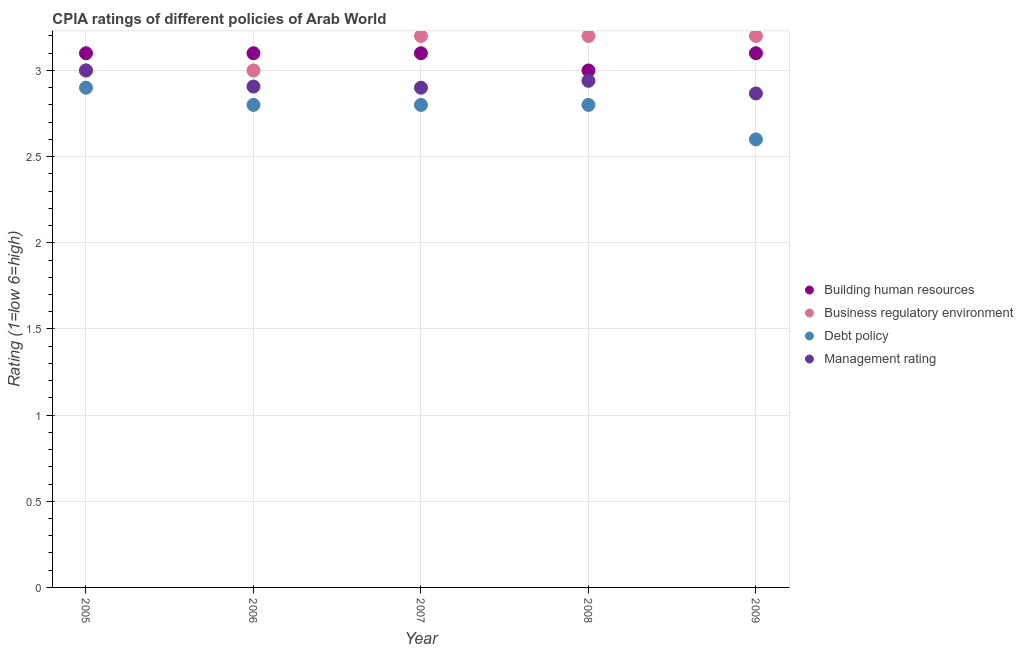What is the cpia rating of business regulatory environment in 2005?
Give a very brief answer. 3. Across all years, what is the minimum cpia rating of business regulatory environment?
Give a very brief answer. 3. In which year was the cpia rating of debt policy minimum?
Ensure brevity in your answer.  2009. What is the total cpia rating of building human resources in the graph?
Ensure brevity in your answer.  15.4. What is the difference between the cpia rating of building human resources in 2005 and that in 2008?
Ensure brevity in your answer.  0.1. What is the difference between the cpia rating of building human resources in 2006 and the cpia rating of management in 2005?
Give a very brief answer. 0.1. What is the average cpia rating of business regulatory environment per year?
Make the answer very short. 3.12. In the year 2009, what is the difference between the cpia rating of management and cpia rating of building human resources?
Offer a terse response. -0.23. In how many years, is the cpia rating of building human resources greater than 2.5?
Make the answer very short. 5. What is the ratio of the cpia rating of management in 2006 to that in 2007?
Ensure brevity in your answer.  1. Is the cpia rating of management in 2007 less than that in 2008?
Make the answer very short. Yes. What is the difference between the highest and the second highest cpia rating of building human resources?
Keep it short and to the point. 0. What is the difference between the highest and the lowest cpia rating of building human resources?
Provide a succinct answer. 0.1. In how many years, is the cpia rating of business regulatory environment greater than the average cpia rating of business regulatory environment taken over all years?
Offer a very short reply. 3. Is the sum of the cpia rating of management in 2008 and 2009 greater than the maximum cpia rating of business regulatory environment across all years?
Make the answer very short. Yes. Is it the case that in every year, the sum of the cpia rating of building human resources and cpia rating of business regulatory environment is greater than the cpia rating of debt policy?
Your response must be concise. Yes. Is the cpia rating of management strictly greater than the cpia rating of building human resources over the years?
Your answer should be compact. No. How many dotlines are there?
Keep it short and to the point. 4. Are the values on the major ticks of Y-axis written in scientific E-notation?
Offer a very short reply. No. Does the graph contain any zero values?
Your answer should be very brief. No. Does the graph contain grids?
Offer a very short reply. Yes. Where does the legend appear in the graph?
Make the answer very short. Center right. How many legend labels are there?
Offer a very short reply. 4. How are the legend labels stacked?
Provide a short and direct response. Vertical. What is the title of the graph?
Keep it short and to the point. CPIA ratings of different policies of Arab World. Does "SF6 gas" appear as one of the legend labels in the graph?
Your response must be concise. No. What is the label or title of the X-axis?
Keep it short and to the point. Year. What is the label or title of the Y-axis?
Provide a short and direct response. Rating (1=low 6=high). What is the Rating (1=low 6=high) in Debt policy in 2005?
Offer a very short reply. 2.9. What is the Rating (1=low 6=high) in Management rating in 2005?
Your response must be concise. 3. What is the Rating (1=low 6=high) of Business regulatory environment in 2006?
Your answer should be very brief. 3. What is the Rating (1=low 6=high) in Management rating in 2006?
Offer a very short reply. 2.91. What is the Rating (1=low 6=high) of Business regulatory environment in 2007?
Your answer should be compact. 3.2. What is the Rating (1=low 6=high) of Debt policy in 2007?
Provide a short and direct response. 2.8. What is the Rating (1=low 6=high) in Management rating in 2007?
Provide a short and direct response. 2.9. What is the Rating (1=low 6=high) of Building human resources in 2008?
Ensure brevity in your answer.  3. What is the Rating (1=low 6=high) in Business regulatory environment in 2008?
Offer a very short reply. 3.2. What is the Rating (1=low 6=high) of Debt policy in 2008?
Provide a succinct answer. 2.8. What is the Rating (1=low 6=high) in Management rating in 2008?
Keep it short and to the point. 2.94. What is the Rating (1=low 6=high) of Building human resources in 2009?
Offer a terse response. 3.1. What is the Rating (1=low 6=high) in Debt policy in 2009?
Provide a succinct answer. 2.6. What is the Rating (1=low 6=high) of Management rating in 2009?
Give a very brief answer. 2.87. Across all years, what is the maximum Rating (1=low 6=high) of Debt policy?
Your answer should be compact. 2.9. Across all years, what is the maximum Rating (1=low 6=high) in Management rating?
Your answer should be very brief. 3. Across all years, what is the minimum Rating (1=low 6=high) of Building human resources?
Offer a terse response. 3. Across all years, what is the minimum Rating (1=low 6=high) in Business regulatory environment?
Provide a succinct answer. 3. Across all years, what is the minimum Rating (1=low 6=high) in Management rating?
Keep it short and to the point. 2.87. What is the total Rating (1=low 6=high) of Building human resources in the graph?
Ensure brevity in your answer.  15.4. What is the total Rating (1=low 6=high) of Management rating in the graph?
Provide a succinct answer. 14.61. What is the difference between the Rating (1=low 6=high) of Business regulatory environment in 2005 and that in 2006?
Give a very brief answer. 0. What is the difference between the Rating (1=low 6=high) in Debt policy in 2005 and that in 2006?
Offer a terse response. 0.1. What is the difference between the Rating (1=low 6=high) of Management rating in 2005 and that in 2006?
Ensure brevity in your answer.  0.09. What is the difference between the Rating (1=low 6=high) of Debt policy in 2005 and that in 2007?
Offer a terse response. 0.1. What is the difference between the Rating (1=low 6=high) of Management rating in 2005 and that in 2009?
Provide a short and direct response. 0.13. What is the difference between the Rating (1=low 6=high) in Management rating in 2006 and that in 2007?
Provide a succinct answer. 0.01. What is the difference between the Rating (1=low 6=high) of Building human resources in 2006 and that in 2008?
Ensure brevity in your answer.  0.1. What is the difference between the Rating (1=low 6=high) of Business regulatory environment in 2006 and that in 2008?
Your answer should be compact. -0.2. What is the difference between the Rating (1=low 6=high) in Debt policy in 2006 and that in 2008?
Ensure brevity in your answer.  0. What is the difference between the Rating (1=low 6=high) of Management rating in 2006 and that in 2008?
Your answer should be very brief. -0.03. What is the difference between the Rating (1=low 6=high) in Building human resources in 2006 and that in 2009?
Your answer should be very brief. 0. What is the difference between the Rating (1=low 6=high) of Business regulatory environment in 2006 and that in 2009?
Offer a terse response. -0.2. What is the difference between the Rating (1=low 6=high) of Debt policy in 2006 and that in 2009?
Your answer should be very brief. 0.2. What is the difference between the Rating (1=low 6=high) in Building human resources in 2007 and that in 2008?
Provide a short and direct response. 0.1. What is the difference between the Rating (1=low 6=high) in Debt policy in 2007 and that in 2008?
Keep it short and to the point. 0. What is the difference between the Rating (1=low 6=high) of Management rating in 2007 and that in 2008?
Provide a short and direct response. -0.04. What is the difference between the Rating (1=low 6=high) in Business regulatory environment in 2007 and that in 2009?
Give a very brief answer. 0. What is the difference between the Rating (1=low 6=high) of Debt policy in 2007 and that in 2009?
Offer a very short reply. 0.2. What is the difference between the Rating (1=low 6=high) of Management rating in 2007 and that in 2009?
Your answer should be compact. 0.03. What is the difference between the Rating (1=low 6=high) in Building human resources in 2008 and that in 2009?
Make the answer very short. -0.1. What is the difference between the Rating (1=low 6=high) of Business regulatory environment in 2008 and that in 2009?
Your response must be concise. 0. What is the difference between the Rating (1=low 6=high) of Management rating in 2008 and that in 2009?
Your answer should be compact. 0.07. What is the difference between the Rating (1=low 6=high) of Building human resources in 2005 and the Rating (1=low 6=high) of Management rating in 2006?
Ensure brevity in your answer.  0.19. What is the difference between the Rating (1=low 6=high) in Business regulatory environment in 2005 and the Rating (1=low 6=high) in Debt policy in 2006?
Provide a short and direct response. 0.2. What is the difference between the Rating (1=low 6=high) in Business regulatory environment in 2005 and the Rating (1=low 6=high) in Management rating in 2006?
Your response must be concise. 0.09. What is the difference between the Rating (1=low 6=high) of Debt policy in 2005 and the Rating (1=low 6=high) of Management rating in 2006?
Give a very brief answer. -0.01. What is the difference between the Rating (1=low 6=high) in Building human resources in 2005 and the Rating (1=low 6=high) in Management rating in 2007?
Your answer should be very brief. 0.2. What is the difference between the Rating (1=low 6=high) of Business regulatory environment in 2005 and the Rating (1=low 6=high) of Debt policy in 2007?
Your answer should be compact. 0.2. What is the difference between the Rating (1=low 6=high) of Debt policy in 2005 and the Rating (1=low 6=high) of Management rating in 2007?
Your answer should be compact. 0. What is the difference between the Rating (1=low 6=high) of Building human resources in 2005 and the Rating (1=low 6=high) of Debt policy in 2008?
Ensure brevity in your answer.  0.3. What is the difference between the Rating (1=low 6=high) of Building human resources in 2005 and the Rating (1=low 6=high) of Management rating in 2008?
Make the answer very short. 0.16. What is the difference between the Rating (1=low 6=high) in Debt policy in 2005 and the Rating (1=low 6=high) in Management rating in 2008?
Give a very brief answer. -0.04. What is the difference between the Rating (1=low 6=high) of Building human resources in 2005 and the Rating (1=low 6=high) of Debt policy in 2009?
Provide a short and direct response. 0.5. What is the difference between the Rating (1=low 6=high) of Building human resources in 2005 and the Rating (1=low 6=high) of Management rating in 2009?
Keep it short and to the point. 0.23. What is the difference between the Rating (1=low 6=high) in Business regulatory environment in 2005 and the Rating (1=low 6=high) in Debt policy in 2009?
Give a very brief answer. 0.4. What is the difference between the Rating (1=low 6=high) in Business regulatory environment in 2005 and the Rating (1=low 6=high) in Management rating in 2009?
Your answer should be very brief. 0.13. What is the difference between the Rating (1=low 6=high) of Debt policy in 2005 and the Rating (1=low 6=high) of Management rating in 2009?
Make the answer very short. 0.03. What is the difference between the Rating (1=low 6=high) in Building human resources in 2006 and the Rating (1=low 6=high) in Debt policy in 2007?
Your answer should be very brief. 0.3. What is the difference between the Rating (1=low 6=high) of Business regulatory environment in 2006 and the Rating (1=low 6=high) of Debt policy in 2007?
Provide a short and direct response. 0.2. What is the difference between the Rating (1=low 6=high) in Building human resources in 2006 and the Rating (1=low 6=high) in Debt policy in 2008?
Your answer should be compact. 0.3. What is the difference between the Rating (1=low 6=high) of Building human resources in 2006 and the Rating (1=low 6=high) of Management rating in 2008?
Provide a succinct answer. 0.16. What is the difference between the Rating (1=low 6=high) of Business regulatory environment in 2006 and the Rating (1=low 6=high) of Debt policy in 2008?
Keep it short and to the point. 0.2. What is the difference between the Rating (1=low 6=high) in Debt policy in 2006 and the Rating (1=low 6=high) in Management rating in 2008?
Provide a succinct answer. -0.14. What is the difference between the Rating (1=low 6=high) in Building human resources in 2006 and the Rating (1=low 6=high) in Debt policy in 2009?
Offer a very short reply. 0.5. What is the difference between the Rating (1=low 6=high) of Building human resources in 2006 and the Rating (1=low 6=high) of Management rating in 2009?
Give a very brief answer. 0.23. What is the difference between the Rating (1=low 6=high) of Business regulatory environment in 2006 and the Rating (1=low 6=high) of Debt policy in 2009?
Offer a very short reply. 0.4. What is the difference between the Rating (1=low 6=high) in Business regulatory environment in 2006 and the Rating (1=low 6=high) in Management rating in 2009?
Ensure brevity in your answer.  0.13. What is the difference between the Rating (1=low 6=high) in Debt policy in 2006 and the Rating (1=low 6=high) in Management rating in 2009?
Ensure brevity in your answer.  -0.07. What is the difference between the Rating (1=low 6=high) in Building human resources in 2007 and the Rating (1=low 6=high) in Business regulatory environment in 2008?
Ensure brevity in your answer.  -0.1. What is the difference between the Rating (1=low 6=high) of Building human resources in 2007 and the Rating (1=low 6=high) of Debt policy in 2008?
Keep it short and to the point. 0.3. What is the difference between the Rating (1=low 6=high) of Building human resources in 2007 and the Rating (1=low 6=high) of Management rating in 2008?
Provide a succinct answer. 0.16. What is the difference between the Rating (1=low 6=high) in Business regulatory environment in 2007 and the Rating (1=low 6=high) in Management rating in 2008?
Ensure brevity in your answer.  0.26. What is the difference between the Rating (1=low 6=high) of Debt policy in 2007 and the Rating (1=low 6=high) of Management rating in 2008?
Give a very brief answer. -0.14. What is the difference between the Rating (1=low 6=high) in Building human resources in 2007 and the Rating (1=low 6=high) in Management rating in 2009?
Give a very brief answer. 0.23. What is the difference between the Rating (1=low 6=high) of Business regulatory environment in 2007 and the Rating (1=low 6=high) of Management rating in 2009?
Give a very brief answer. 0.33. What is the difference between the Rating (1=low 6=high) in Debt policy in 2007 and the Rating (1=low 6=high) in Management rating in 2009?
Ensure brevity in your answer.  -0.07. What is the difference between the Rating (1=low 6=high) in Building human resources in 2008 and the Rating (1=low 6=high) in Management rating in 2009?
Offer a very short reply. 0.13. What is the difference between the Rating (1=low 6=high) in Business regulatory environment in 2008 and the Rating (1=low 6=high) in Debt policy in 2009?
Provide a short and direct response. 0.6. What is the difference between the Rating (1=low 6=high) in Business regulatory environment in 2008 and the Rating (1=low 6=high) in Management rating in 2009?
Ensure brevity in your answer.  0.33. What is the difference between the Rating (1=low 6=high) in Debt policy in 2008 and the Rating (1=low 6=high) in Management rating in 2009?
Offer a very short reply. -0.07. What is the average Rating (1=low 6=high) in Building human resources per year?
Offer a very short reply. 3.08. What is the average Rating (1=low 6=high) of Business regulatory environment per year?
Offer a very short reply. 3.12. What is the average Rating (1=low 6=high) in Debt policy per year?
Keep it short and to the point. 2.78. What is the average Rating (1=low 6=high) in Management rating per year?
Your answer should be very brief. 2.92. In the year 2005, what is the difference between the Rating (1=low 6=high) in Building human resources and Rating (1=low 6=high) in Business regulatory environment?
Your answer should be very brief. 0.1. In the year 2005, what is the difference between the Rating (1=low 6=high) in Building human resources and Rating (1=low 6=high) in Management rating?
Your response must be concise. 0.1. In the year 2005, what is the difference between the Rating (1=low 6=high) of Business regulatory environment and Rating (1=low 6=high) of Debt policy?
Ensure brevity in your answer.  0.1. In the year 2005, what is the difference between the Rating (1=low 6=high) of Business regulatory environment and Rating (1=low 6=high) of Management rating?
Keep it short and to the point. 0. In the year 2005, what is the difference between the Rating (1=low 6=high) of Debt policy and Rating (1=low 6=high) of Management rating?
Provide a short and direct response. -0.1. In the year 2006, what is the difference between the Rating (1=low 6=high) in Building human resources and Rating (1=low 6=high) in Management rating?
Your answer should be compact. 0.19. In the year 2006, what is the difference between the Rating (1=low 6=high) in Business regulatory environment and Rating (1=low 6=high) in Management rating?
Offer a very short reply. 0.09. In the year 2006, what is the difference between the Rating (1=low 6=high) in Debt policy and Rating (1=low 6=high) in Management rating?
Provide a short and direct response. -0.11. In the year 2007, what is the difference between the Rating (1=low 6=high) in Business regulatory environment and Rating (1=low 6=high) in Debt policy?
Offer a terse response. 0.4. In the year 2007, what is the difference between the Rating (1=low 6=high) in Business regulatory environment and Rating (1=low 6=high) in Management rating?
Offer a terse response. 0.3. In the year 2008, what is the difference between the Rating (1=low 6=high) of Building human resources and Rating (1=low 6=high) of Business regulatory environment?
Your answer should be very brief. -0.2. In the year 2008, what is the difference between the Rating (1=low 6=high) in Building human resources and Rating (1=low 6=high) in Management rating?
Give a very brief answer. 0.06. In the year 2008, what is the difference between the Rating (1=low 6=high) of Business regulatory environment and Rating (1=low 6=high) of Debt policy?
Your answer should be compact. 0.4. In the year 2008, what is the difference between the Rating (1=low 6=high) of Business regulatory environment and Rating (1=low 6=high) of Management rating?
Give a very brief answer. 0.26. In the year 2008, what is the difference between the Rating (1=low 6=high) in Debt policy and Rating (1=low 6=high) in Management rating?
Your answer should be very brief. -0.14. In the year 2009, what is the difference between the Rating (1=low 6=high) of Building human resources and Rating (1=low 6=high) of Management rating?
Provide a succinct answer. 0.23. In the year 2009, what is the difference between the Rating (1=low 6=high) of Debt policy and Rating (1=low 6=high) of Management rating?
Provide a short and direct response. -0.27. What is the ratio of the Rating (1=low 6=high) of Business regulatory environment in 2005 to that in 2006?
Keep it short and to the point. 1. What is the ratio of the Rating (1=low 6=high) in Debt policy in 2005 to that in 2006?
Provide a short and direct response. 1.04. What is the ratio of the Rating (1=low 6=high) of Management rating in 2005 to that in 2006?
Make the answer very short. 1.03. What is the ratio of the Rating (1=low 6=high) of Debt policy in 2005 to that in 2007?
Your response must be concise. 1.04. What is the ratio of the Rating (1=low 6=high) in Management rating in 2005 to that in 2007?
Offer a terse response. 1.03. What is the ratio of the Rating (1=low 6=high) of Building human resources in 2005 to that in 2008?
Your answer should be very brief. 1.03. What is the ratio of the Rating (1=low 6=high) of Debt policy in 2005 to that in 2008?
Offer a very short reply. 1.04. What is the ratio of the Rating (1=low 6=high) in Management rating in 2005 to that in 2008?
Your answer should be compact. 1.02. What is the ratio of the Rating (1=low 6=high) of Business regulatory environment in 2005 to that in 2009?
Your answer should be very brief. 0.94. What is the ratio of the Rating (1=low 6=high) of Debt policy in 2005 to that in 2009?
Keep it short and to the point. 1.12. What is the ratio of the Rating (1=low 6=high) in Management rating in 2005 to that in 2009?
Offer a very short reply. 1.05. What is the ratio of the Rating (1=low 6=high) of Business regulatory environment in 2006 to that in 2007?
Ensure brevity in your answer.  0.94. What is the ratio of the Rating (1=low 6=high) of Building human resources in 2006 to that in 2008?
Offer a very short reply. 1.03. What is the ratio of the Rating (1=low 6=high) in Business regulatory environment in 2006 to that in 2008?
Offer a terse response. 0.94. What is the ratio of the Rating (1=low 6=high) of Management rating in 2006 to that in 2008?
Make the answer very short. 0.99. What is the ratio of the Rating (1=low 6=high) of Business regulatory environment in 2006 to that in 2009?
Make the answer very short. 0.94. What is the ratio of the Rating (1=low 6=high) in Building human resources in 2007 to that in 2008?
Make the answer very short. 1.03. What is the ratio of the Rating (1=low 6=high) of Debt policy in 2007 to that in 2008?
Your answer should be compact. 1. What is the ratio of the Rating (1=low 6=high) of Management rating in 2007 to that in 2008?
Give a very brief answer. 0.99. What is the ratio of the Rating (1=low 6=high) in Business regulatory environment in 2007 to that in 2009?
Your response must be concise. 1. What is the ratio of the Rating (1=low 6=high) of Debt policy in 2007 to that in 2009?
Your answer should be very brief. 1.08. What is the ratio of the Rating (1=low 6=high) of Management rating in 2007 to that in 2009?
Your response must be concise. 1.01. What is the ratio of the Rating (1=low 6=high) in Business regulatory environment in 2008 to that in 2009?
Provide a succinct answer. 1. What is the ratio of the Rating (1=low 6=high) in Management rating in 2008 to that in 2009?
Your response must be concise. 1.03. What is the difference between the highest and the second highest Rating (1=low 6=high) of Building human resources?
Offer a terse response. 0. What is the difference between the highest and the second highest Rating (1=low 6=high) of Business regulatory environment?
Your answer should be compact. 0. What is the difference between the highest and the second highest Rating (1=low 6=high) of Debt policy?
Make the answer very short. 0.1. What is the difference between the highest and the second highest Rating (1=low 6=high) in Management rating?
Make the answer very short. 0.06. What is the difference between the highest and the lowest Rating (1=low 6=high) of Building human resources?
Give a very brief answer. 0.1. What is the difference between the highest and the lowest Rating (1=low 6=high) of Debt policy?
Offer a terse response. 0.3. What is the difference between the highest and the lowest Rating (1=low 6=high) of Management rating?
Offer a very short reply. 0.13. 